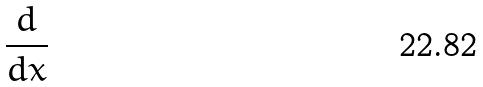Convert formula to latex. <formula><loc_0><loc_0><loc_500><loc_500>\frac { d } { d x }</formula> 